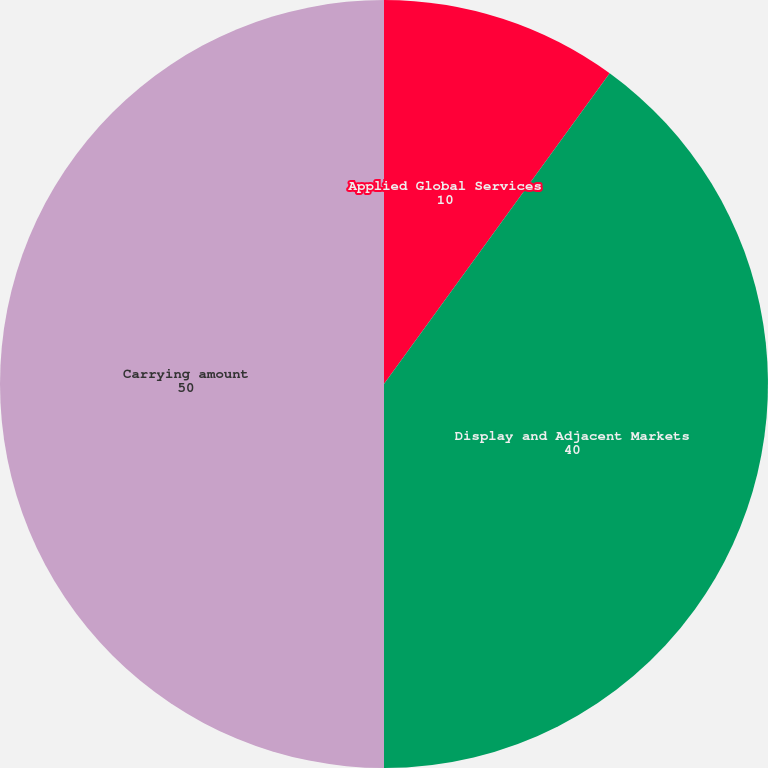Convert chart. <chart><loc_0><loc_0><loc_500><loc_500><pie_chart><fcel>Applied Global Services<fcel>Display and Adjacent Markets<fcel>Carrying amount<nl><fcel>10.0%<fcel>40.0%<fcel>50.0%<nl></chart> 